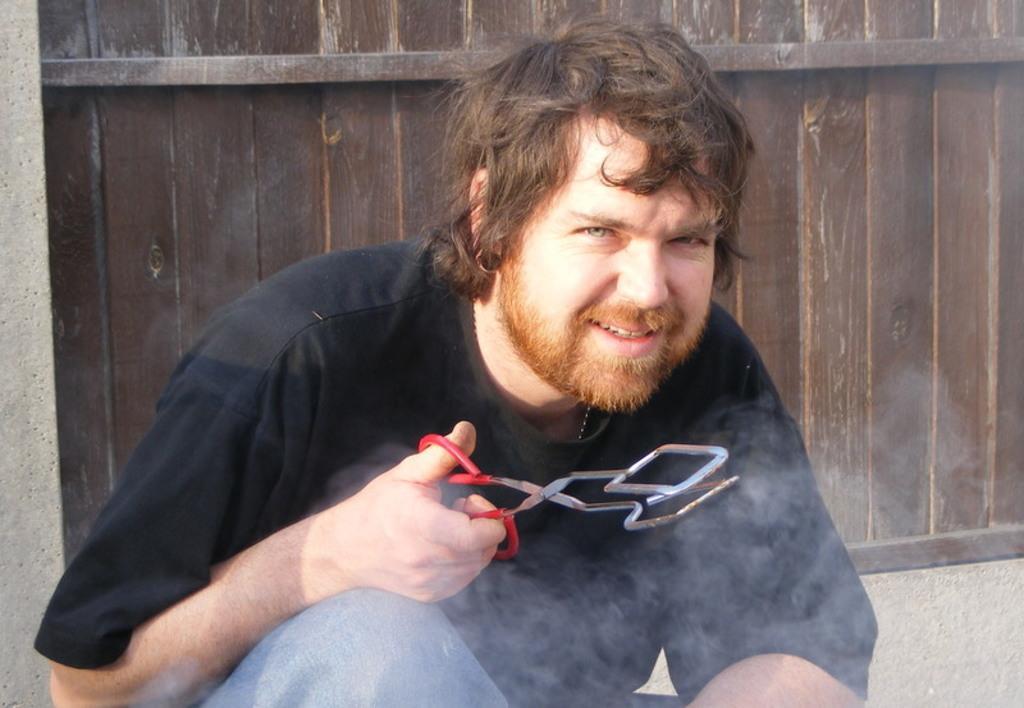In one or two sentences, can you explain what this image depicts? This image consists of a man sitting on the road. He is wearing a black T-shirt. He is holding a scissors. In the background, there is a wall made up of wood. At the bottom, there is a road. 